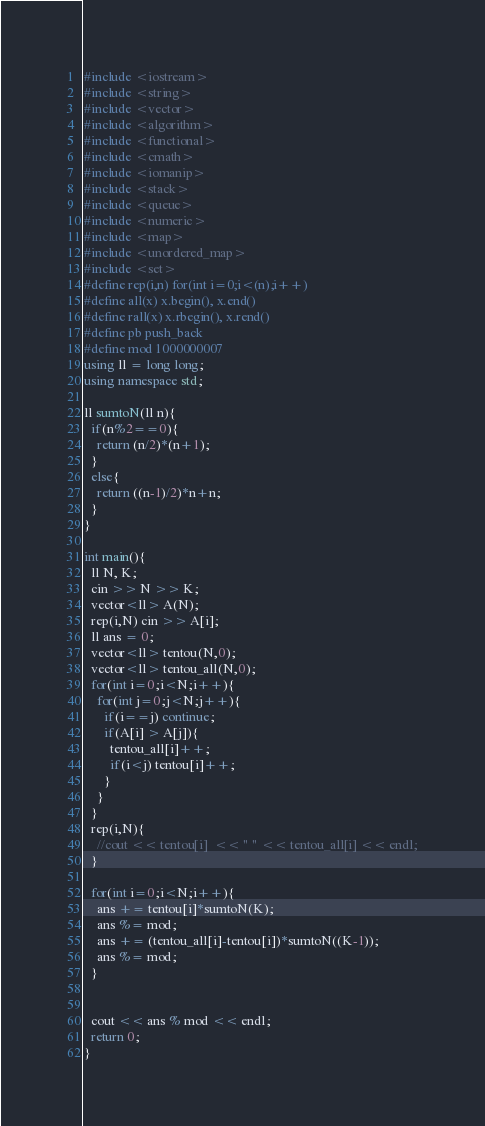Convert code to text. <code><loc_0><loc_0><loc_500><loc_500><_C++_>#include <iostream>
#include <string>
#include <vector>
#include <algorithm>
#include <functional>
#include <cmath>
#include <iomanip>
#include <stack>
#include <queue>
#include <numeric>
#include <map>
#include <unordered_map>
#include <set>
#define rep(i,n) for(int i=0;i<(n);i++)
#define all(x) x.begin(), x.end()
#define rall(x) x.rbegin(), x.rend()
#define pb push_back
#define mod 1000000007
using ll = long long;
using namespace std;

ll sumtoN(ll n){
  if(n%2==0){
    return (n/2)*(n+1);
  }
  else{
    return ((n-1)/2)*n+n;
  }
}

int main(){
  ll N, K;
  cin >> N >> K;
  vector<ll> A(N);
  rep(i,N) cin >> A[i];
  ll ans = 0;
  vector<ll> tentou(N,0);
  vector<ll> tentou_all(N,0);
  for(int i=0;i<N;i++){
    for(int j=0;j<N;j++){
      if(i==j) continue;
      if(A[i] > A[j]){
        tentou_all[i]++;
        if(i<j) tentou[i]++;
      }
    }
  }
  rep(i,N){
    //cout << tentou[i]  << " " << tentou_all[i] << endl;
  }

  for(int i=0;i<N;i++){
    ans += tentou[i]*sumtoN(K);
    ans %= mod;
    ans += (tentou_all[i]-tentou[i])*sumtoN((K-1));
    ans %= mod;
  }


  cout << ans % mod << endl;
  return 0;
}
</code> 